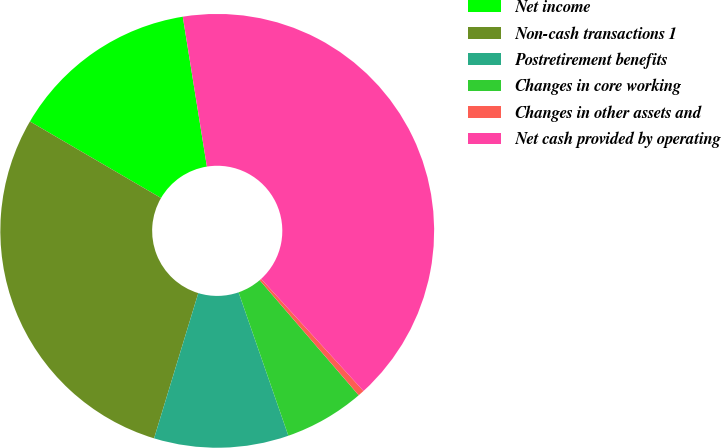Convert chart to OTSL. <chart><loc_0><loc_0><loc_500><loc_500><pie_chart><fcel>Net income<fcel>Non-cash transactions 1<fcel>Postretirement benefits<fcel>Changes in core working<fcel>Changes in other assets and<fcel>Net cash provided by operating<nl><fcel>14.05%<fcel>28.71%<fcel>10.02%<fcel>5.99%<fcel>0.47%<fcel>40.76%<nl></chart> 